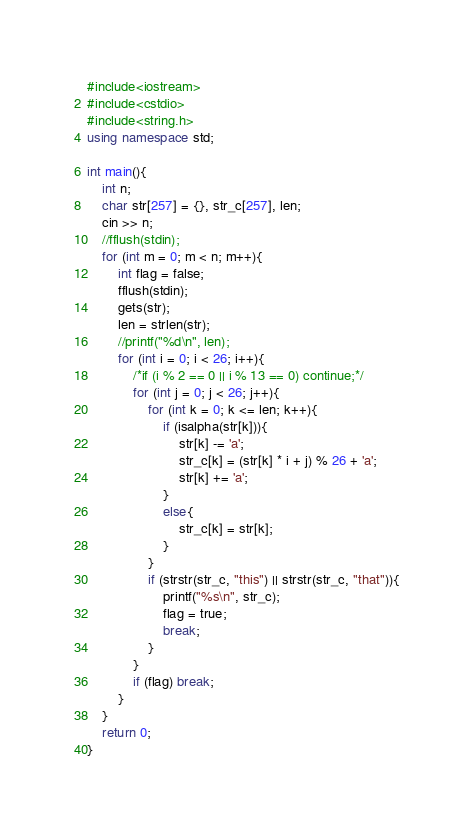Convert code to text. <code><loc_0><loc_0><loc_500><loc_500><_C++_>#include<iostream>
#include<cstdio>
#include<string.h>
using namespace std;

int main(){
	int n;
	char str[257] = {}, str_c[257], len;
	cin >> n;
	//fflush(stdin);
	for (int m = 0; m < n; m++){
		int flag = false;
		fflush(stdin);
		gets(str);
		len = strlen(str);
		//printf("%d\n", len);
		for (int i = 0; i < 26; i++){
			/*if (i % 2 == 0 || i % 13 == 0) continue;*/
			for (int j = 0; j < 26; j++){
				for (int k = 0; k <= len; k++){
					if (isalpha(str[k])){
						str[k] -= 'a';
						str_c[k] = (str[k] * i + j) % 26 + 'a';
						str[k] += 'a';
					}
					else{
						str_c[k] = str[k];
					}
				}
				if (strstr(str_c, "this") || strstr(str_c, "that")){
					printf("%s\n", str_c);
					flag = true;
					break;
				}
			}
			if (flag) break;
		}
	}
	return 0;
}</code> 